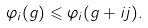<formula> <loc_0><loc_0><loc_500><loc_500>\varphi _ { i } ( g ) \leqslant \varphi _ { i } ( g + i j ) .</formula> 